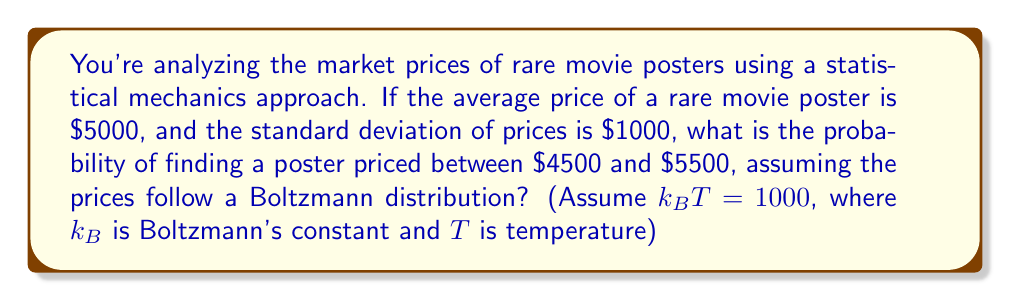Could you help me with this problem? Let's approach this step-by-step:

1) In statistical mechanics, the Boltzmann distribution is given by:

   $$P(E) = \frac{1}{Z} e^{-E/k_B T}$$

   where $E$ is energy (in our case, price), $k_B$ is Boltzmann's constant, $T$ is temperature, and $Z$ is the partition function.

2) For a continuous distribution of prices, this becomes a normal distribution with mean $\mu$ and standard deviation $\sigma$:

   $$P(x) = \frac{1}{\sigma \sqrt{2\pi}} e^{-(x-\mu)^2 / 2\sigma^2}$$

3) We're given:
   $\mu = 5000$
   $\sigma = 1000$
   $k_B T = 1000$

4) To find the probability between $4500 and $5500, we need to integrate:

   $$P(4500 \leq x \leq 5500) = \int_{4500}^{5500} \frac{1}{1000 \sqrt{2\pi}} e^{-(x-5000)^2 / 2(1000)^2} dx$$

5) This is equivalent to finding the area under the standard normal curve between $z = -0.5$ and $z = 0.5$, where:

   $$z = \frac{x - \mu}{\sigma}$$

6) We can use the standard normal table or a calculator to find this probability:

   $$P(-0.5 \leq z \leq 0.5) = 0.3829$$

Therefore, the probability of finding a poster priced between $4500 and $5500 is approximately 0.3829 or 38.29%.
Answer: 0.3829 